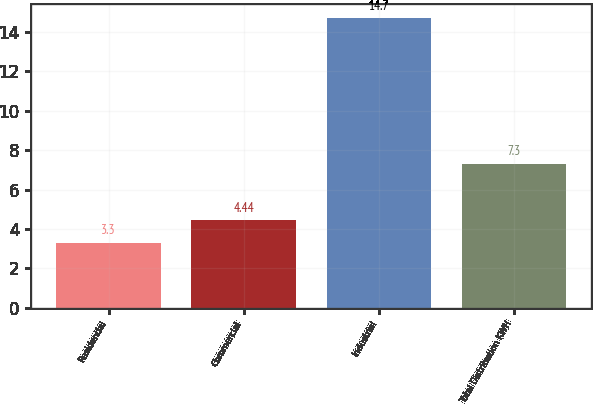<chart> <loc_0><loc_0><loc_500><loc_500><bar_chart><fcel>Residential<fcel>Commercial<fcel>Industrial<fcel>Total Distribution KWH<nl><fcel>3.3<fcel>4.44<fcel>14.7<fcel>7.3<nl></chart> 